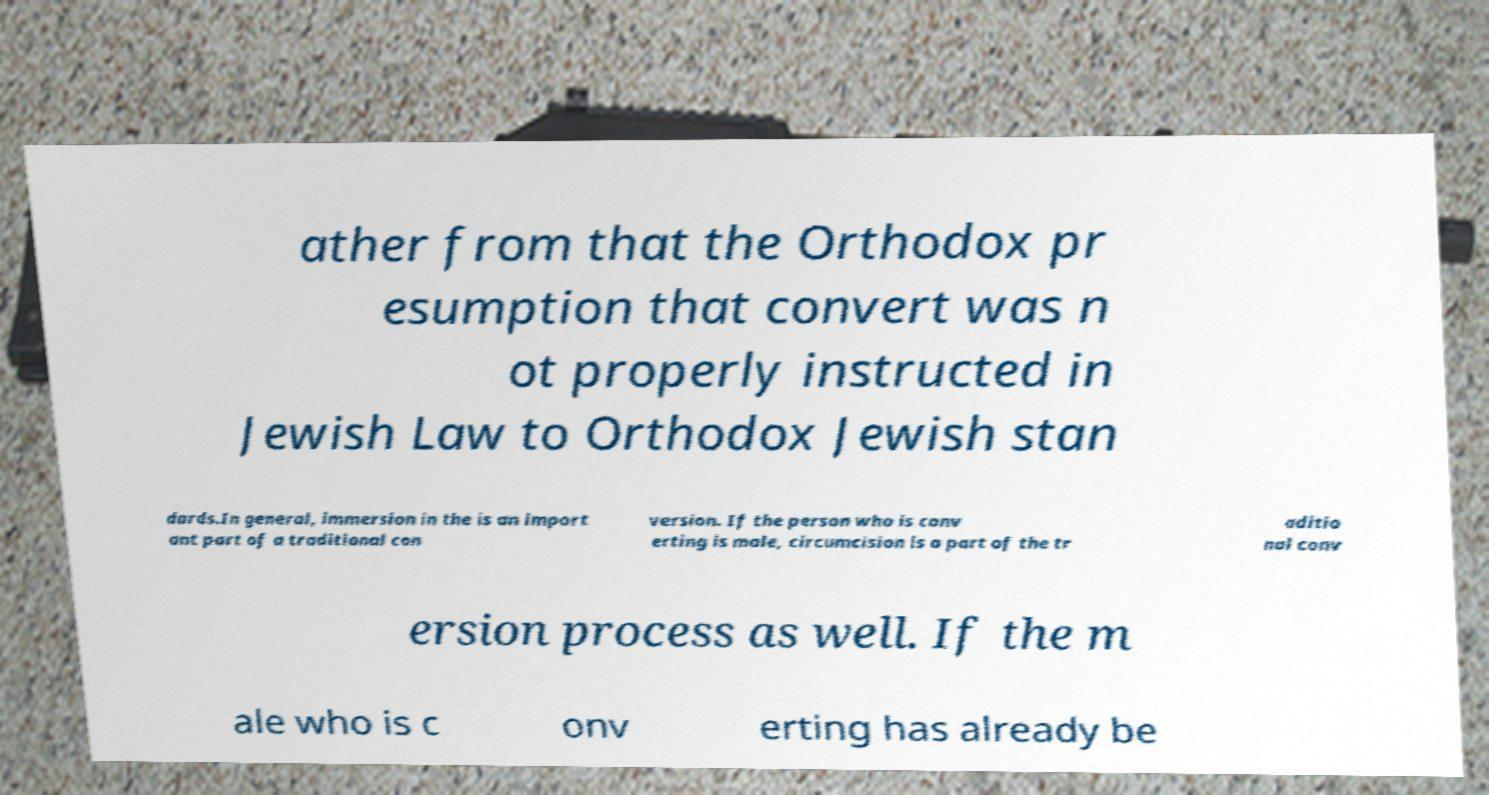Could you assist in decoding the text presented in this image and type it out clearly? ather from that the Orthodox pr esumption that convert was n ot properly instructed in Jewish Law to Orthodox Jewish stan dards.In general, immersion in the is an import ant part of a traditional con version. If the person who is conv erting is male, circumcision is a part of the tr aditio nal conv ersion process as well. If the m ale who is c onv erting has already be 